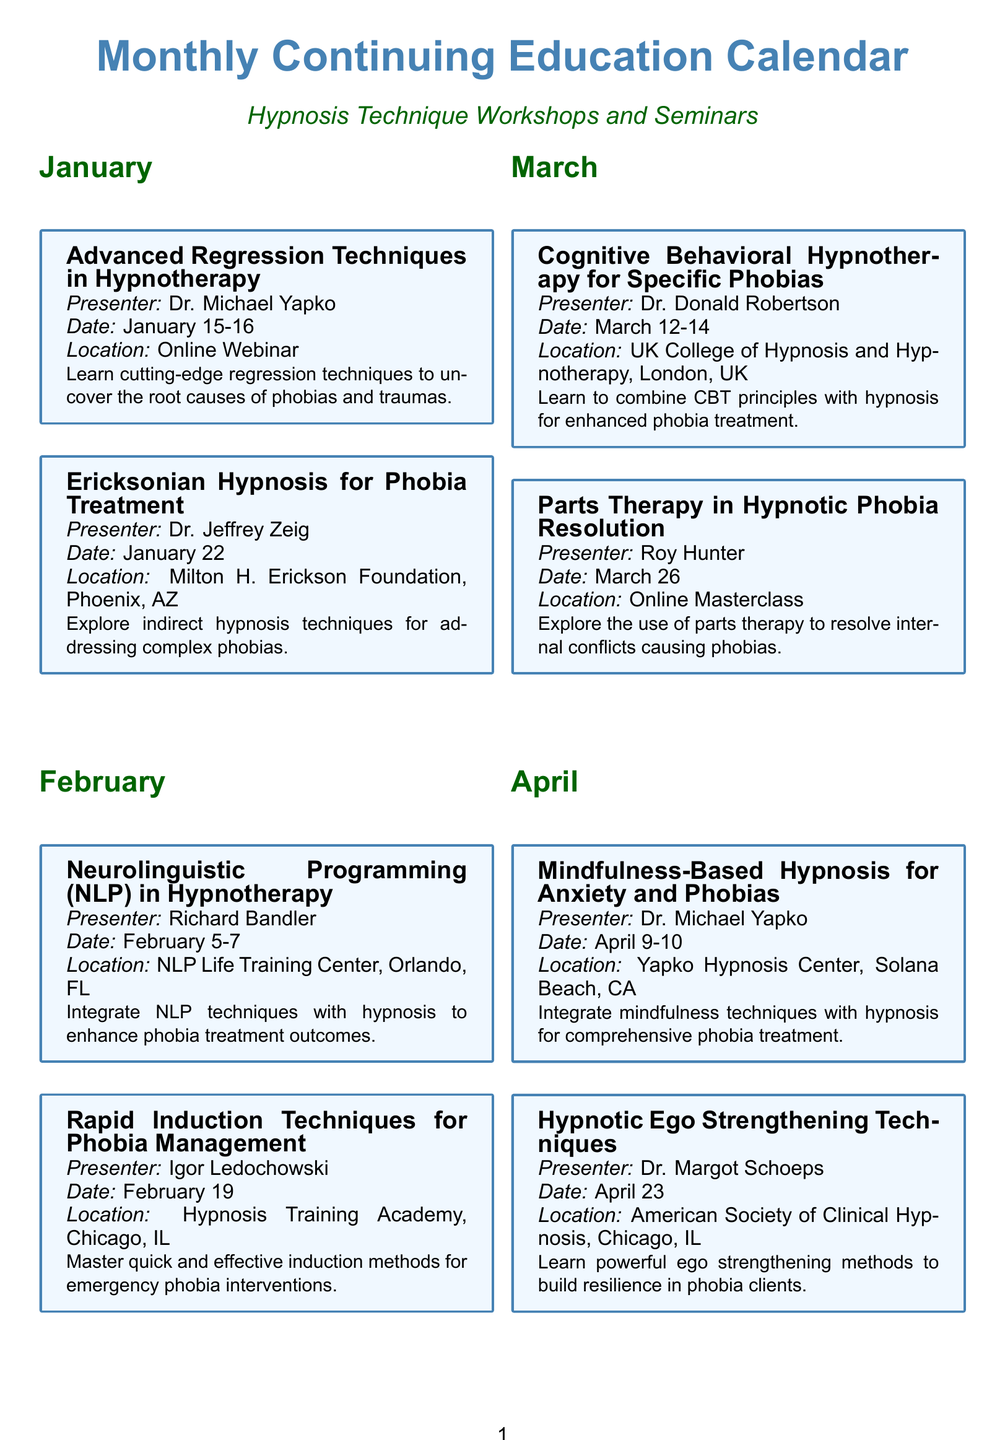What is the title of the workshop in January focused on regression techniques? The title is found in the January section of the document, referring to advanced techniques for uncovering phobia and trauma causes.
Answer: Advanced Regression Techniques in Hypnotherapy Who is the presenter for the workshop on Pediatric Hypnosis in July? The presenter is listed under the July section, where the specific workshop about childhood phobias is detailed.
Answer: Dr. Daniel Kohen How many workshops are scheduled for March? The number of workshops can be counted in the March section of the document, presenting two distinct workshops.
Answer: 2 What is the date of the workshop on Hypnotic Strategies for Managing Performance Anxiety? The date can be found in the December section, detailing when this specific workshop is taking place.
Answer: December 17 Where is the Neurolinguistic Programming workshop being held? The location can be retrieved from the February section, specifying the venue for this particular workshop.
Answer: NLP Life Training Center, Orlando, FL Which month features a workshop by Dr. Carol Ginandes? The respective month is identified by scanning through the workshops and noting when this presenter is scheduled.
Answer: May What is the main focus of the workshop on Hypnotic Ego Strengthening Techniques? The focus can be deduced from the description provided in the April section, indicating the purpose of the techniques taught.
Answer: Build resilience in phobia clients In what format is the Advanced Ideomotor Techniques workshop being conducted? The format can be extracted from the December section, showing whether it's an in-person event or online.
Answer: American Society of Clinical Hypnosis, New Orleans, LA What unique approach is discussed in August's workshop on Virtual Reality-Enhanced Hypnosis? The approach can be inferred from the description associated with the workshop listed in August, summarizing its innovation.
Answer: VR technology in hypnotic phobia interventions 